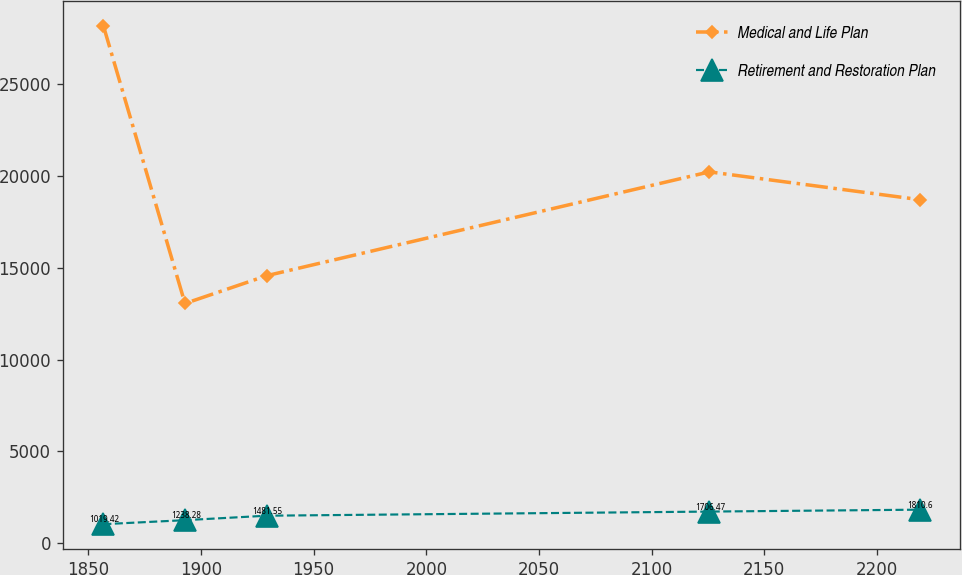<chart> <loc_0><loc_0><loc_500><loc_500><line_chart><ecel><fcel>Medical and Life Plan<fcel>Retirement and Restoration Plan<nl><fcel>1856.65<fcel>28200.5<fcel>1019.42<nl><fcel>1892.88<fcel>13055.5<fcel>1238.28<nl><fcel>1929.11<fcel>14570<fcel>1481.55<nl><fcel>2125.62<fcel>20232.8<fcel>1706.47<nl><fcel>2218.91<fcel>18718.3<fcel>1810.6<nl></chart> 